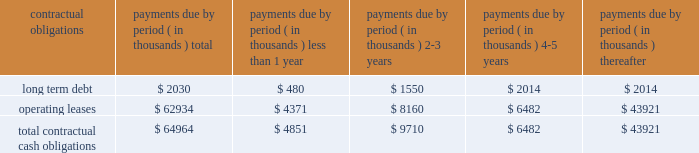Under this line are primarily used by our european subsidiaries to settle intercompany sales and are denominated in the respective local currencies of its european subsidiaries .
The line of credit may be canceled by the bank with 30 days notice .
At september 27 , 2003 , there were no outstanding borrowings under this line .
In september 2001 we obtained a secured loan from wells fargo foothill , inc .
The loan agreement with wells fargo foothill , inc .
Provides for a term loan of approximately $ 2.4 million , which we borrowed at signing , and a revolving line of credit facility .
The maximum amount we can borrow under the loan agreement and amendments is $ 20.0 million .
The loan agreement and amendments contain financial and other covenants and the actual amount which we can borrow under the line of credit at any time is based upon a formula tied to the amount of our qualifying accounts receivable .
In july 2003 we amended this loan agreement primarily to simplify financial covenants and to reduce the fees related to this facility .
The term loan accrues interest at prime plus 1.0% ( 1.0 % ) for five years .
The line of credit advances accrue interest at prime plus 0.25% ( 0.25 % ) .
The line of credit expires in september 2005 .
We were in compliance with all covenants as of september 27 , 2003 .
In april 2002 , we began an implementation project for an integrated enterprise wide software application .
We began operational use of this software application at the bedford , ma and newark , de facilities on november 24 , 2002 , at the danbury , ct facility on february 24 , 2003 and at the brussels , belgium location on october 2 , 2003 .
Through september 27 , 2003 we have made payments totaling $ 3.4 million for hardware , software and consulting services representing substantially all of our capital commitments related to this implementation project .
Most of the cost has been capitalized and we began to amortize these costs over their expected useful lives in december 2002 .
In september 2002 , we completed a sale/leaseback transaction for our headquarters and manufacturing facility located in bedford , massachusetts and our lorad manufacturing facility in danbury , connecticut .
The transaction resulted in net proceeds to us of $ 31.4 million .
The new lease for these facilities , including the associated land , has a term of 20 years , with four five-year year renewal terms , which we may exercise at our option .
The basic rent for the facilities is $ 3.2 million per year , which is subject to adjustment for increases in the consumer price index .
The aggregate total minimum lease payments during the initial 20-year term are $ 62.9 million .
In addition , we are required to maintain the facilities during the term of the lease and to pay all taxes , insurance , utilities and other costs associated with those facilities .
Under the lease , we make customary representations and warranties and agree to certain financial covenants and indemnities .
In the event we default on the lease , the landlord may terminate the lease , accelerate payments and collect liquidated damages .
The table summarizes our contractual obligations and commitments as of september 27 , 2003 : payments due by period ( in thousands ) contractual obligations total less than 1 year years thereafter .
Except as set forth above , we do not have any other significant capital commitments .
We are working on several projects , with an emphasis on direct radiography plates .
We believe that we have sufficient funds in order to fund our expected operations over the next twelve months .
Recent accounting pronouncements in december 2002 , sfas no .
148 , accounting for stock-based compensation 2013 transition and disclosure was issued .
Sfas no .
148 amends sfas no .
123 to provide alternative methods of transition to the fair value method of accounting for stock-based employee compensation .
In addition , sfas no .
148 amends the disclosure provisions of sfas no .
123 to require disclosure in the summary of significant accounting policies of the effects .
What percentage of total contractual obligations and commitments as of september 27 , 2003 : payments due is composed of operating leases? 
Computations: (62934 / 64964)
Answer: 0.96875. 